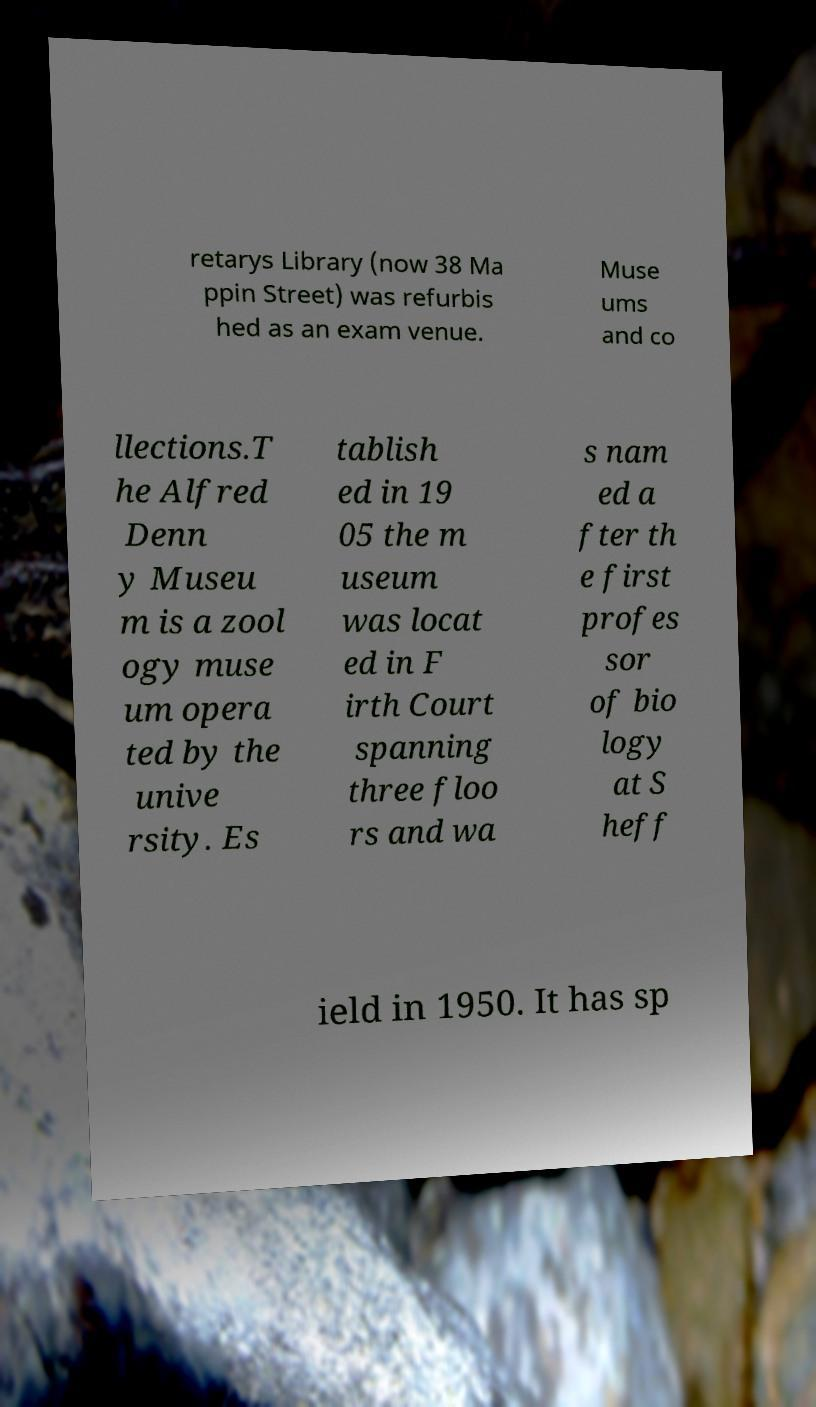Could you extract and type out the text from this image? retarys Library (now 38 Ma ppin Street) was refurbis hed as an exam venue. Muse ums and co llections.T he Alfred Denn y Museu m is a zool ogy muse um opera ted by the unive rsity. Es tablish ed in 19 05 the m useum was locat ed in F irth Court spanning three floo rs and wa s nam ed a fter th e first profes sor of bio logy at S heff ield in 1950. It has sp 